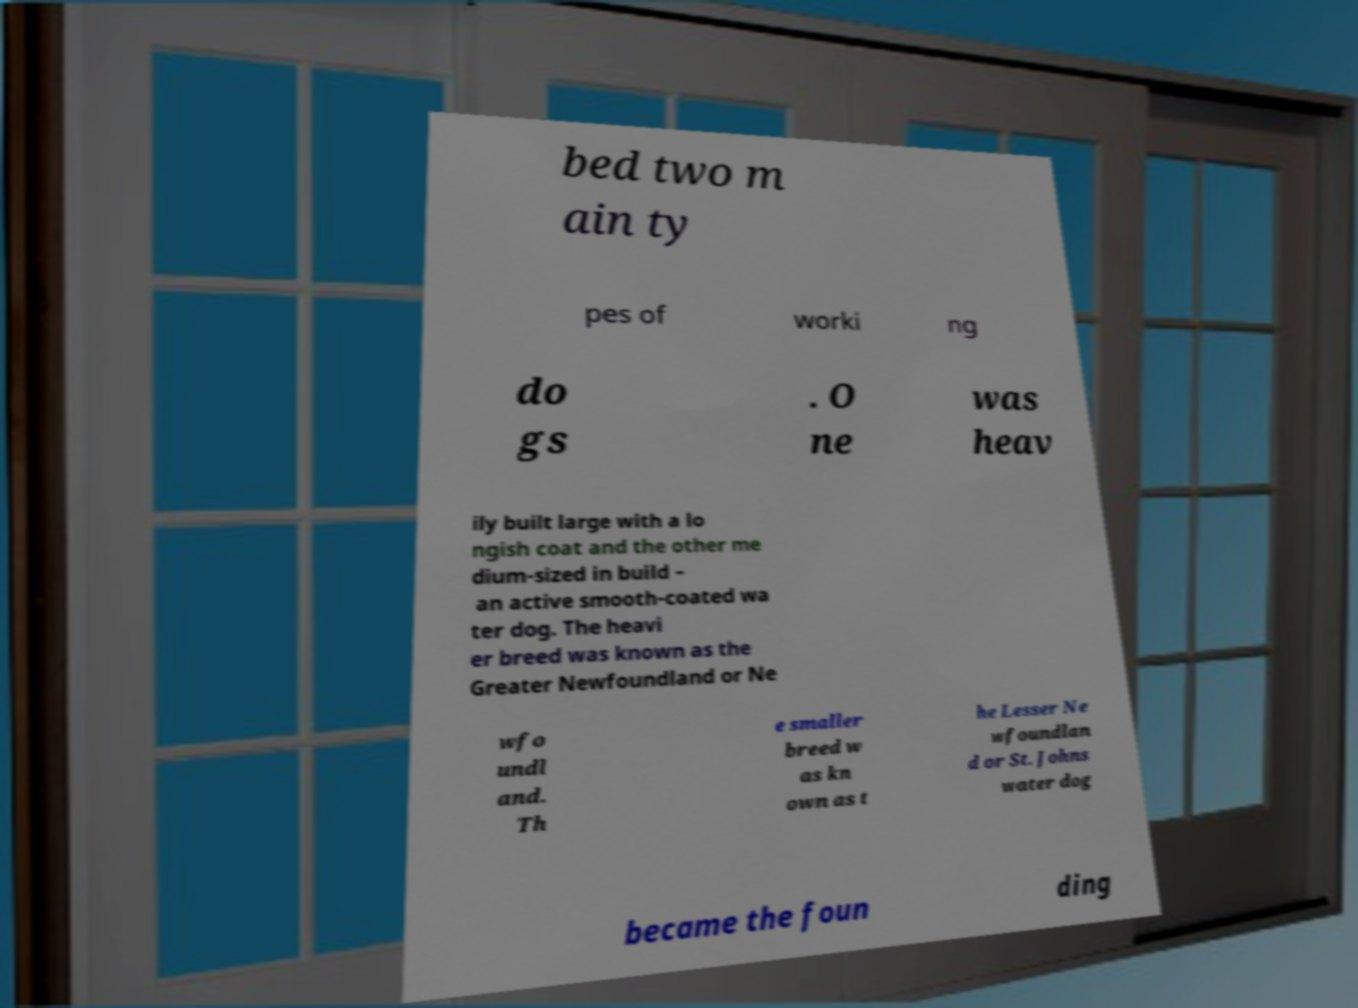What messages or text are displayed in this image? I need them in a readable, typed format. bed two m ain ty pes of worki ng do gs . O ne was heav ily built large with a lo ngish coat and the other me dium-sized in build – an active smooth-coated wa ter dog. The heavi er breed was known as the Greater Newfoundland or Ne wfo undl and. Th e smaller breed w as kn own as t he Lesser Ne wfoundlan d or St. Johns water dog became the foun ding 